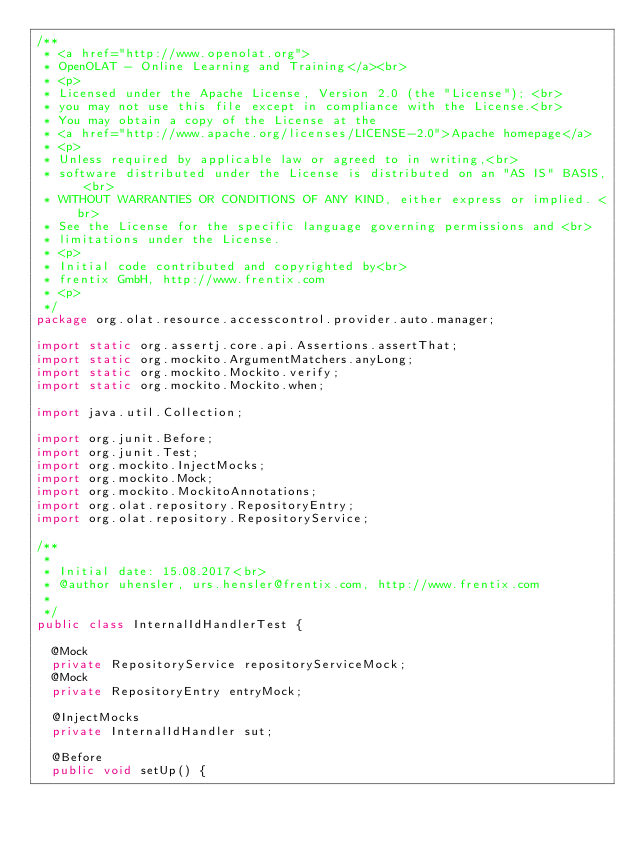Convert code to text. <code><loc_0><loc_0><loc_500><loc_500><_Java_>/**
 * <a href="http://www.openolat.org">
 * OpenOLAT - Online Learning and Training</a><br>
 * <p>
 * Licensed under the Apache License, Version 2.0 (the "License"); <br>
 * you may not use this file except in compliance with the License.<br>
 * You may obtain a copy of the License at the
 * <a href="http://www.apache.org/licenses/LICENSE-2.0">Apache homepage</a>
 * <p>
 * Unless required by applicable law or agreed to in writing,<br>
 * software distributed under the License is distributed on an "AS IS" BASIS, <br>
 * WITHOUT WARRANTIES OR CONDITIONS OF ANY KIND, either express or implied. <br>
 * See the License for the specific language governing permissions and <br>
 * limitations under the License.
 * <p>
 * Initial code contributed and copyrighted by<br>
 * frentix GmbH, http://www.frentix.com
 * <p>
 */
package org.olat.resource.accesscontrol.provider.auto.manager;

import static org.assertj.core.api.Assertions.assertThat;
import static org.mockito.ArgumentMatchers.anyLong;
import static org.mockito.Mockito.verify;
import static org.mockito.Mockito.when;

import java.util.Collection;

import org.junit.Before;
import org.junit.Test;
import org.mockito.InjectMocks;
import org.mockito.Mock;
import org.mockito.MockitoAnnotations;
import org.olat.repository.RepositoryEntry;
import org.olat.repository.RepositoryService;

/**
 *
 * Initial date: 15.08.2017<br>
 * @author uhensler, urs.hensler@frentix.com, http://www.frentix.com
 *
 */
public class InternalIdHandlerTest {

	@Mock
	private RepositoryService repositoryServiceMock;
	@Mock
	private RepositoryEntry entryMock;

	@InjectMocks
	private InternalIdHandler sut;

	@Before
	public void setUp() {</code> 